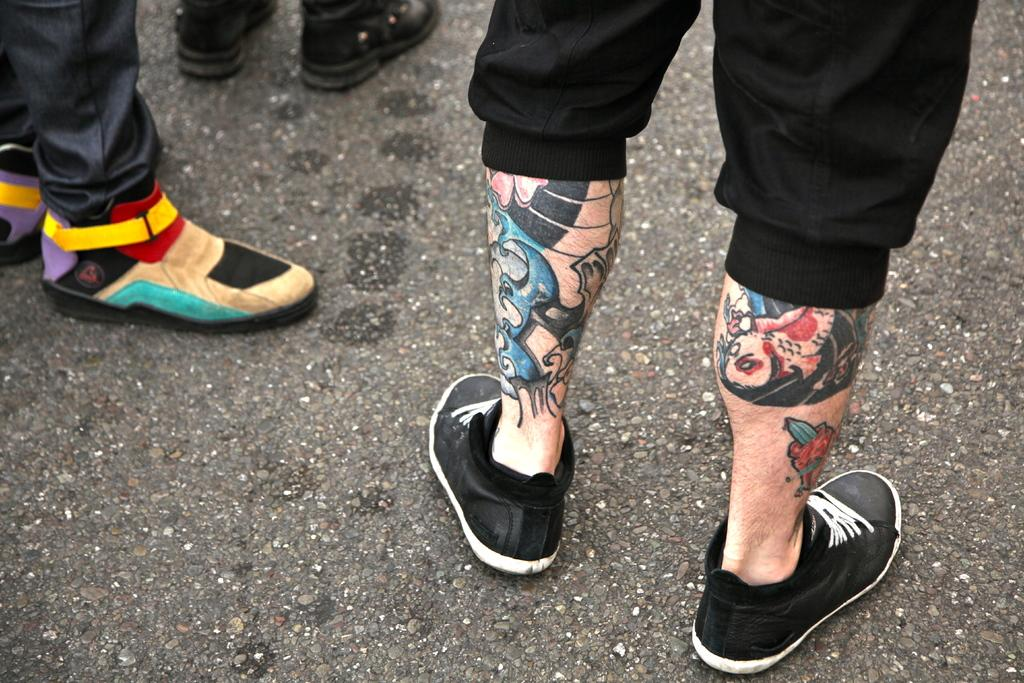How many people are present in the image? There are three persons in the image, as indicated by the presence of their legs. What are the people wearing on their feet? The three persons are wearing shoes. What can be seen at the bottom of the image? There is a road visible at the bottom of the image. What type of flag is being blown by the wind in the image? There is no flag present in the image, so it cannot be determined if any flag is being blown by the wind. 